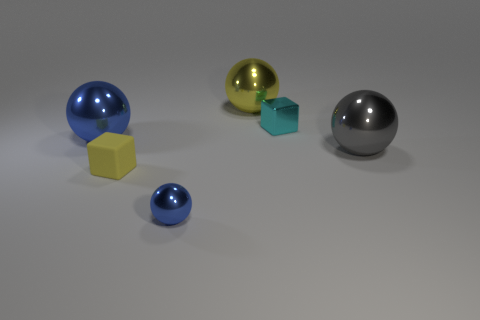Subtract all big blue metal spheres. How many spheres are left? 3 Add 1 small cyan objects. How many objects exist? 7 Subtract all gray balls. How many balls are left? 3 Subtract 1 cubes. How many cubes are left? 1 Subtract all blocks. How many objects are left? 4 Add 5 yellow objects. How many yellow objects are left? 7 Add 4 tiny cyan rubber things. How many tiny cyan rubber things exist? 4 Subtract 0 green balls. How many objects are left? 6 Subtract all gray blocks. Subtract all purple spheres. How many blocks are left? 2 Subtract all red spheres. How many brown cubes are left? 0 